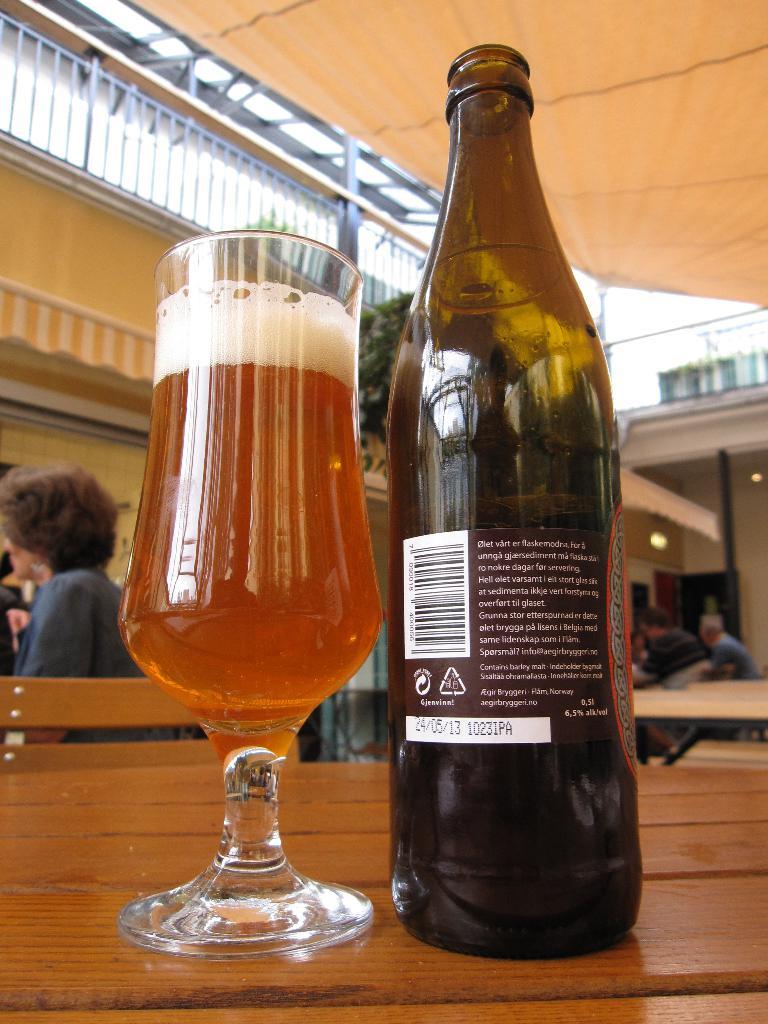What are the numbers after the date?
Give a very brief answer. 1023. What date in on the label?
Give a very brief answer. 24/05/13. 